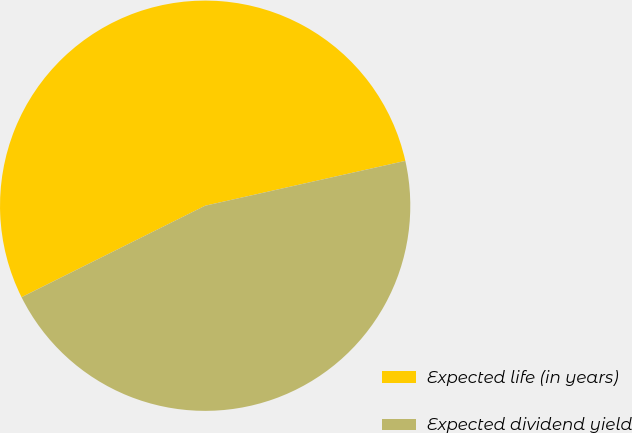<chart> <loc_0><loc_0><loc_500><loc_500><pie_chart><fcel>Expected life (in years)<fcel>Expected dividend yield<nl><fcel>53.85%<fcel>46.15%<nl></chart> 